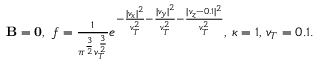<formula> <loc_0><loc_0><loc_500><loc_500>\begin{array} { r } { { \mathbf B } = { \mathbf 0 } , \ f = \frac { 1 } { \pi ^ { \frac { 3 } { 2 } } v _ { T } ^ { \frac { 3 } { 2 } } } e ^ { - \frac { | v _ { x } | ^ { 2 } } { v _ { T } ^ { 2 } } - \frac { | v _ { y } | ^ { 2 } } { v _ { T } ^ { 2 } } - \frac { | v _ { z } - 0 . 1 | ^ { 2 } } { v _ { T } ^ { 2 } } } , \, \kappa = 1 , \, v _ { T } = 0 . 1 . } \end{array}</formula> 